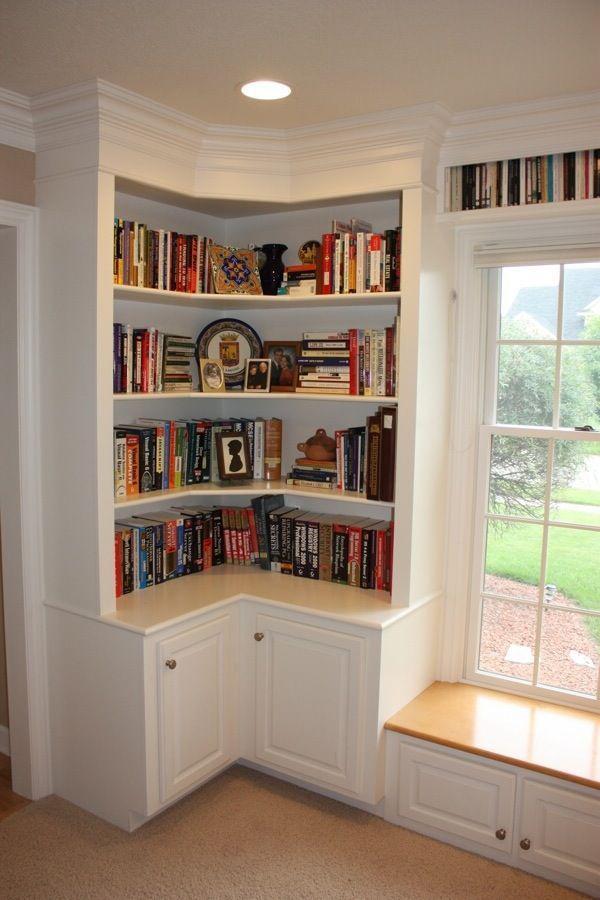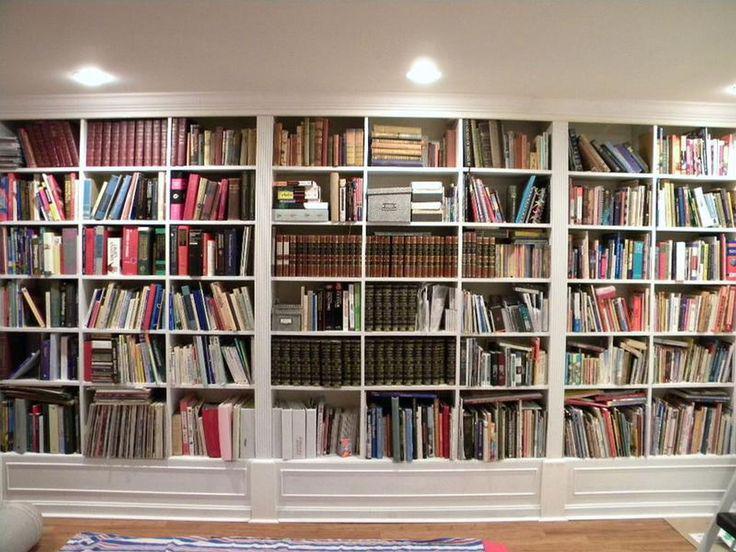The first image is the image on the left, the second image is the image on the right. Evaluate the accuracy of this statement regarding the images: "One set of shelves has a built in window bench.". Is it true? Answer yes or no. Yes. 